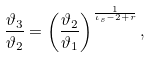Convert formula to latex. <formula><loc_0><loc_0><loc_500><loc_500>\frac { \vartheta _ { 3 } } { \vartheta _ { 2 } } = \left ( \frac { \vartheta _ { 2 } } { \vartheta _ { 1 } } \right ) ^ { \frac { 1 } { \iota _ { s } - 2 + r } } ,</formula> 